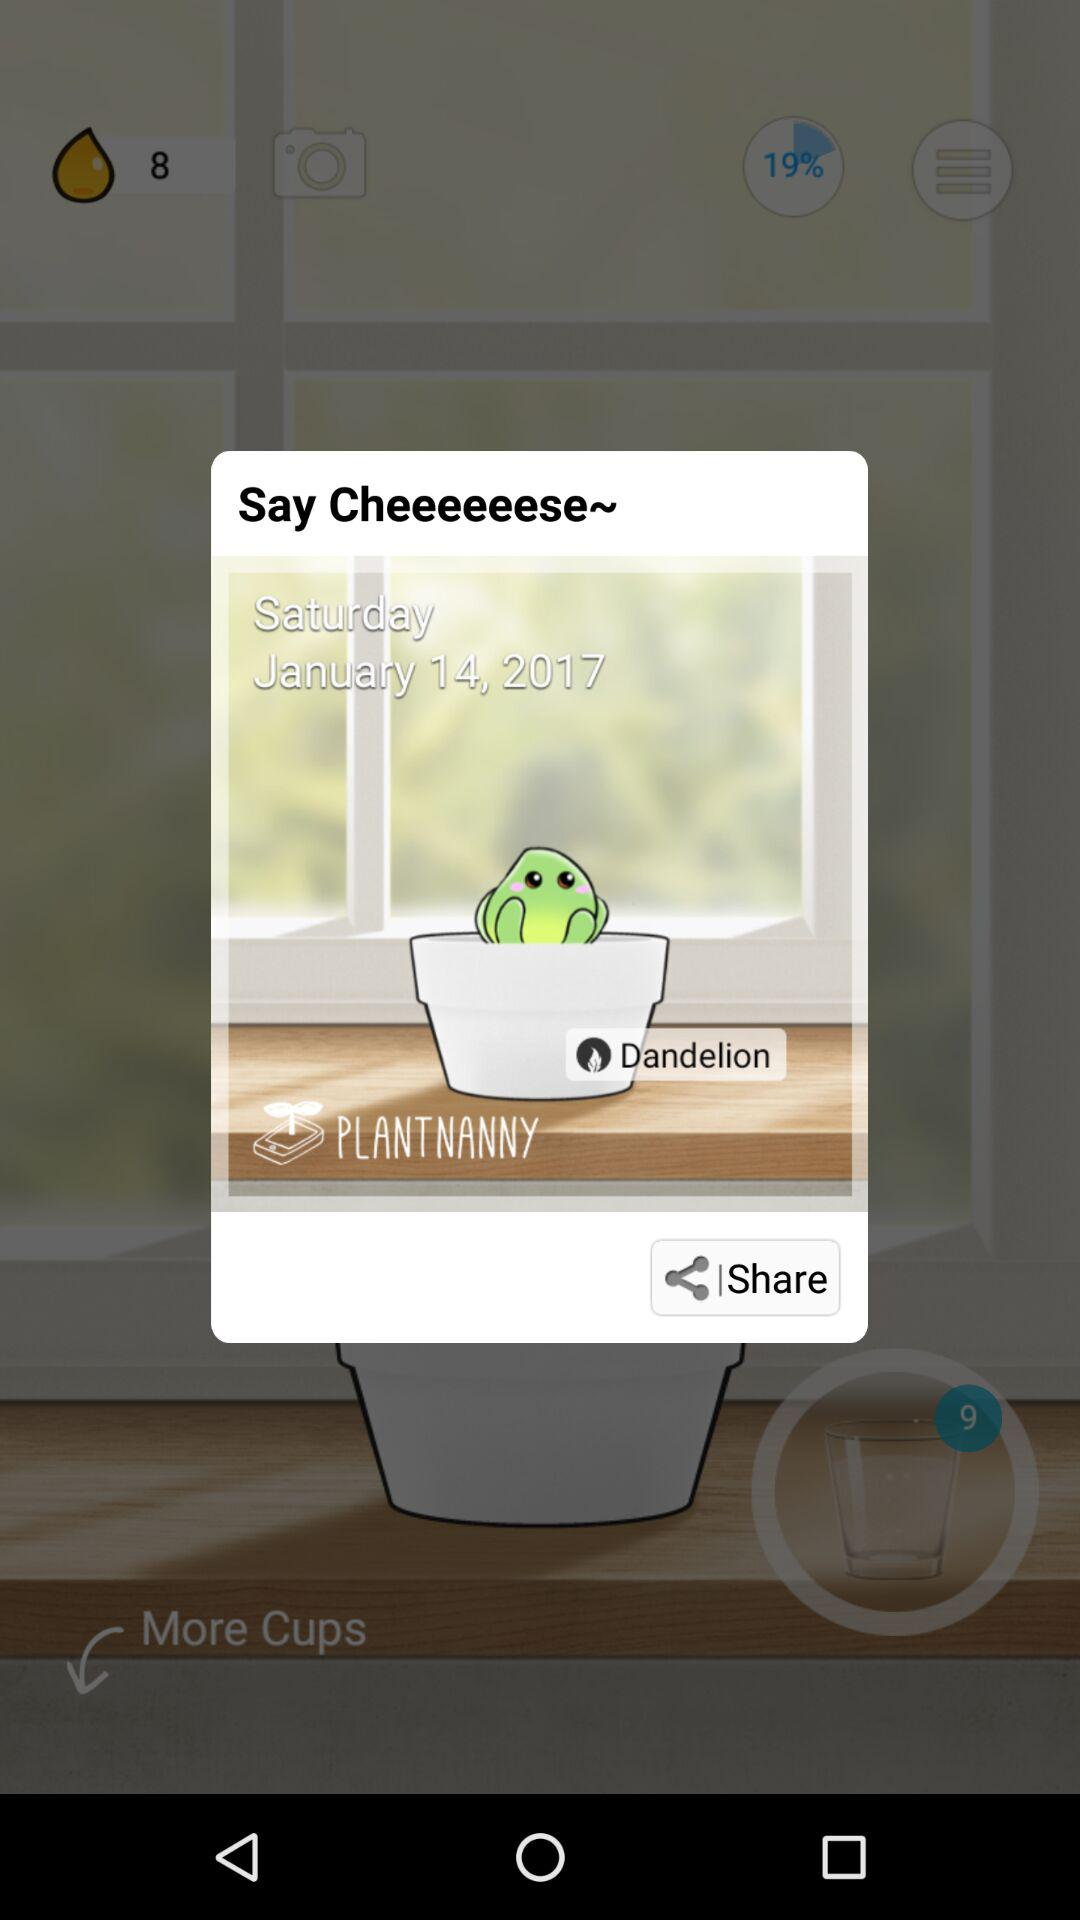What is the date? The date is Saturday, January 14, 2017. 